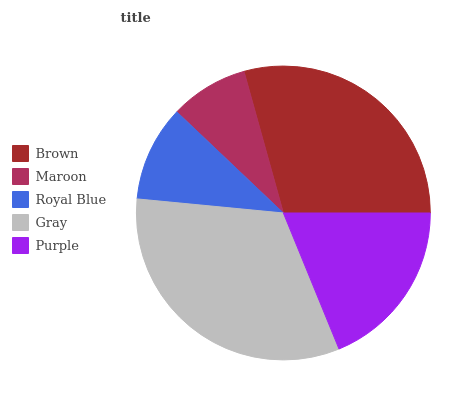Is Maroon the minimum?
Answer yes or no. Yes. Is Gray the maximum?
Answer yes or no. Yes. Is Royal Blue the minimum?
Answer yes or no. No. Is Royal Blue the maximum?
Answer yes or no. No. Is Royal Blue greater than Maroon?
Answer yes or no. Yes. Is Maroon less than Royal Blue?
Answer yes or no. Yes. Is Maroon greater than Royal Blue?
Answer yes or no. No. Is Royal Blue less than Maroon?
Answer yes or no. No. Is Purple the high median?
Answer yes or no. Yes. Is Purple the low median?
Answer yes or no. Yes. Is Gray the high median?
Answer yes or no. No. Is Gray the low median?
Answer yes or no. No. 